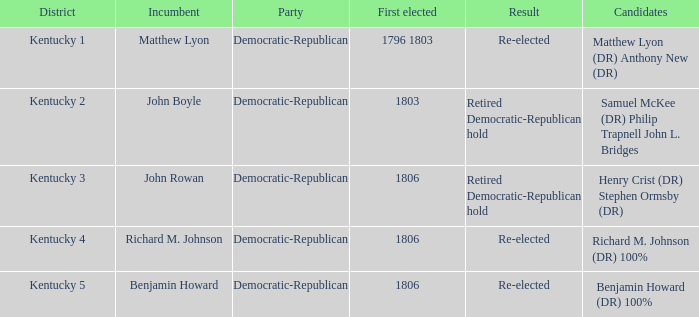In kentucky, what is the number of political parties? 1.0. 